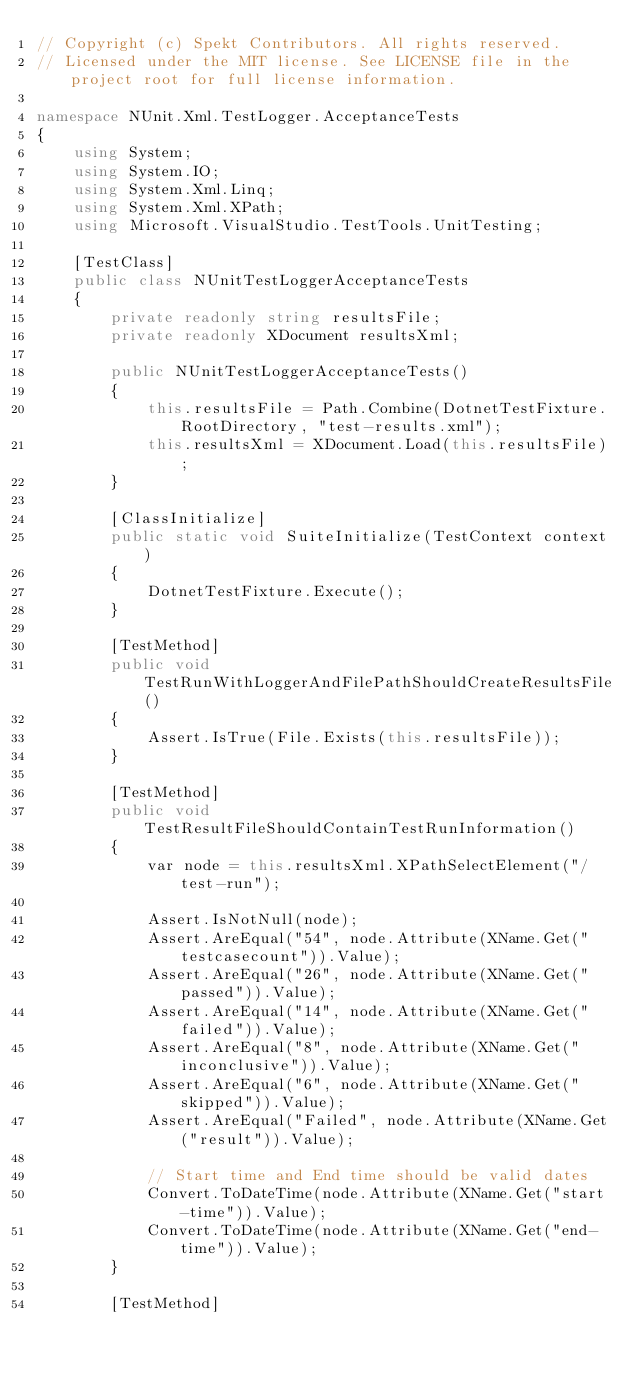<code> <loc_0><loc_0><loc_500><loc_500><_C#_>// Copyright (c) Spekt Contributors. All rights reserved.
// Licensed under the MIT license. See LICENSE file in the project root for full license information.

namespace NUnit.Xml.TestLogger.AcceptanceTests
{
    using System;
    using System.IO;
    using System.Xml.Linq;
    using System.Xml.XPath;
    using Microsoft.VisualStudio.TestTools.UnitTesting;

    [TestClass]
    public class NUnitTestLoggerAcceptanceTests
    {
        private readonly string resultsFile;
        private readonly XDocument resultsXml;

        public NUnitTestLoggerAcceptanceTests()
        {
            this.resultsFile = Path.Combine(DotnetTestFixture.RootDirectory, "test-results.xml");
            this.resultsXml = XDocument.Load(this.resultsFile);
        }

        [ClassInitialize]
        public static void SuiteInitialize(TestContext context)
        {
            DotnetTestFixture.Execute();
        }

        [TestMethod]
        public void TestRunWithLoggerAndFilePathShouldCreateResultsFile()
        {
            Assert.IsTrue(File.Exists(this.resultsFile));
        }

        [TestMethod]
        public void TestResultFileShouldContainTestRunInformation()
        {
            var node = this.resultsXml.XPathSelectElement("/test-run");

            Assert.IsNotNull(node);
            Assert.AreEqual("54", node.Attribute(XName.Get("testcasecount")).Value);
            Assert.AreEqual("26", node.Attribute(XName.Get("passed")).Value);
            Assert.AreEqual("14", node.Attribute(XName.Get("failed")).Value);
            Assert.AreEqual("8", node.Attribute(XName.Get("inconclusive")).Value);
            Assert.AreEqual("6", node.Attribute(XName.Get("skipped")).Value);
            Assert.AreEqual("Failed", node.Attribute(XName.Get("result")).Value);

            // Start time and End time should be valid dates
            Convert.ToDateTime(node.Attribute(XName.Get("start-time")).Value);
            Convert.ToDateTime(node.Attribute(XName.Get("end-time")).Value);
        }

        [TestMethod]</code> 